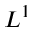Convert formula to latex. <formula><loc_0><loc_0><loc_500><loc_500>L ^ { 1 }</formula> 